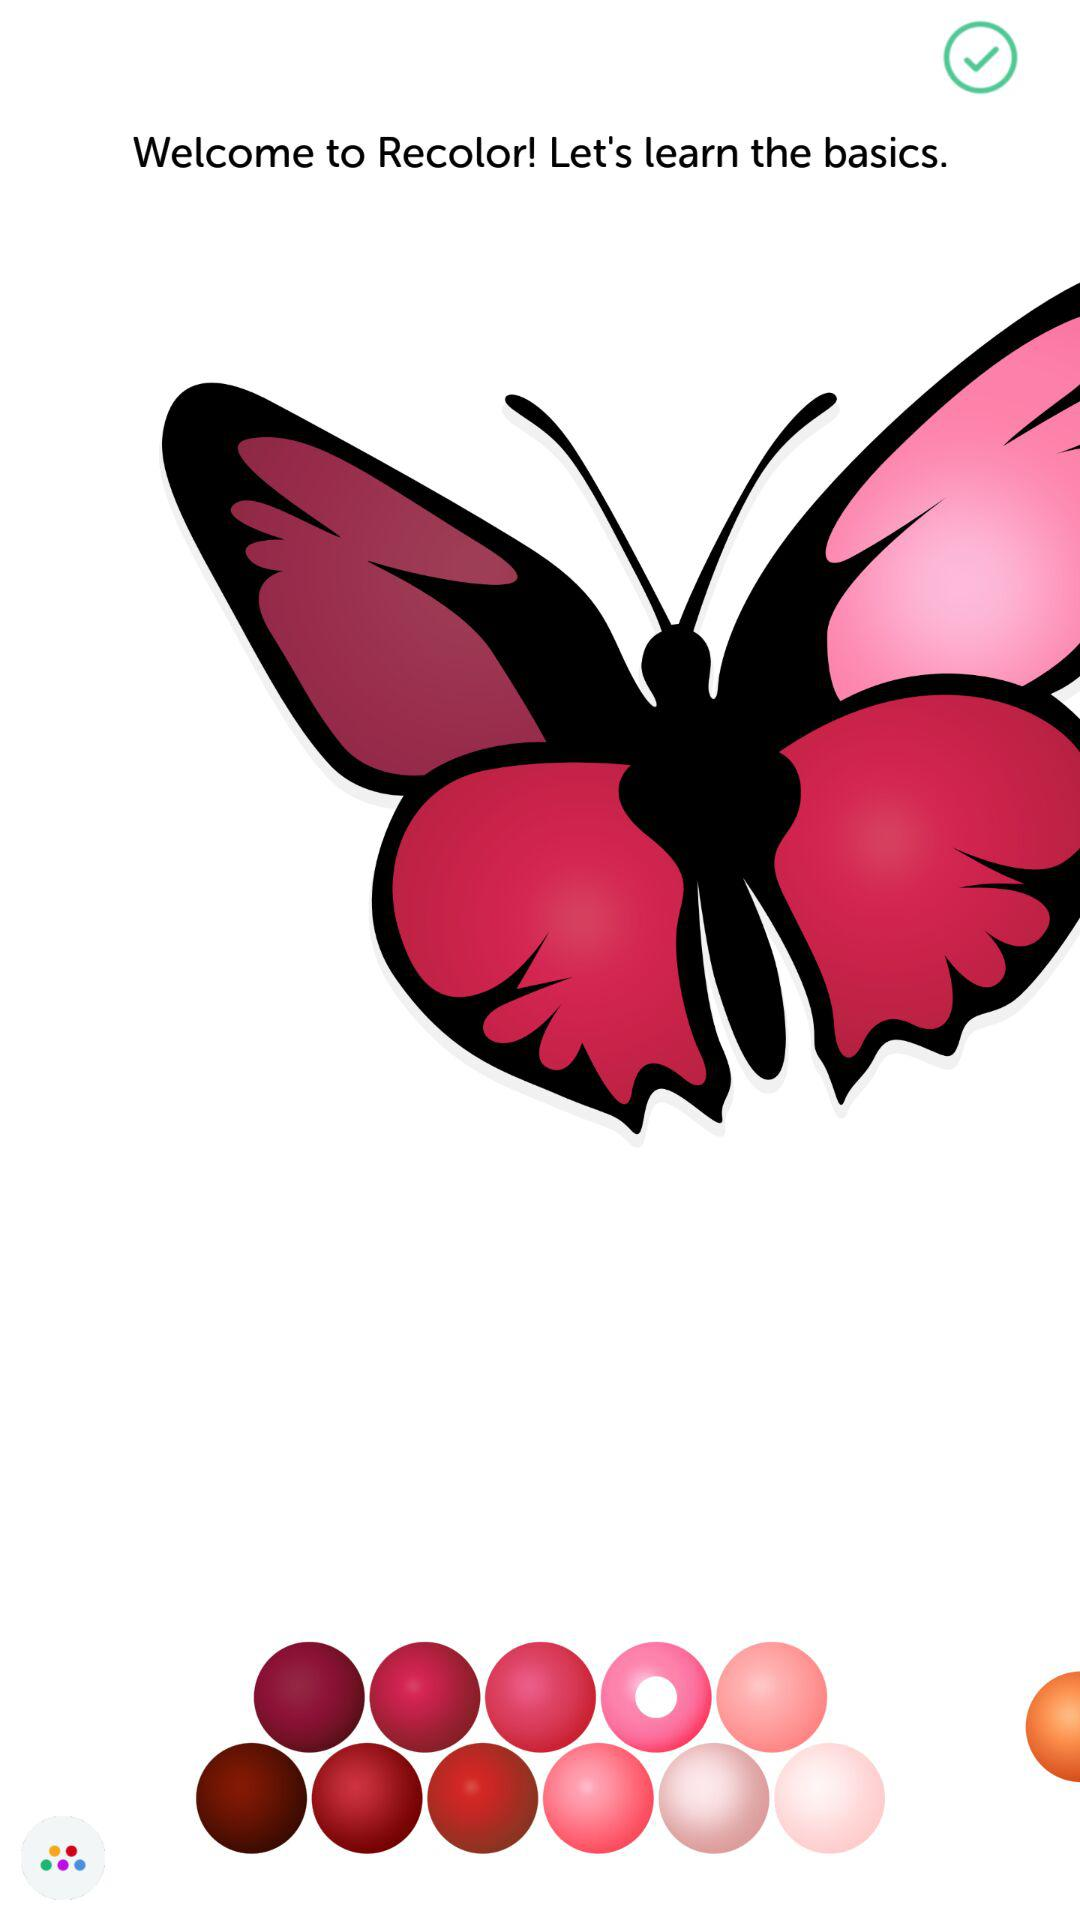Who developed "Recolor"?
When the provided information is insufficient, respond with <no answer>. <no answer> 